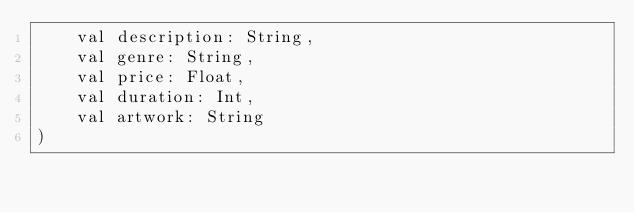<code> <loc_0><loc_0><loc_500><loc_500><_Kotlin_>    val description: String,
    val genre: String,
    val price: Float,
    val duration: Int,
    val artwork: String
)</code> 